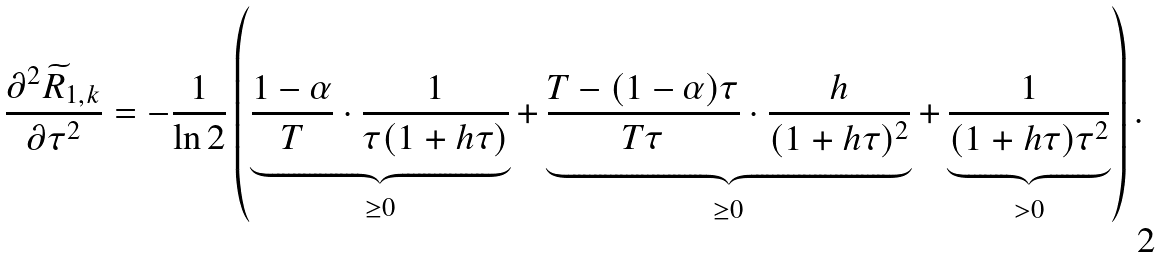Convert formula to latex. <formula><loc_0><loc_0><loc_500><loc_500>\frac { \partial ^ { 2 } \widetilde { R } _ { 1 , k } } { \partial \tau ^ { 2 } } = - \frac { 1 } { \ln 2 } \left ( \underbrace { \frac { 1 - \alpha } { T } \cdot \frac { 1 } { \tau ( 1 + h \tau ) } } _ { \geq 0 } + \underbrace { \frac { T - ( 1 - \alpha ) \tau } { T \tau } \cdot \frac { h } { ( 1 + h \tau ) ^ { 2 } } } _ { \geq 0 } + \underbrace { \frac { 1 } { ( 1 + h \tau ) \tau ^ { 2 } } } _ { > 0 } \right ) .</formula> 